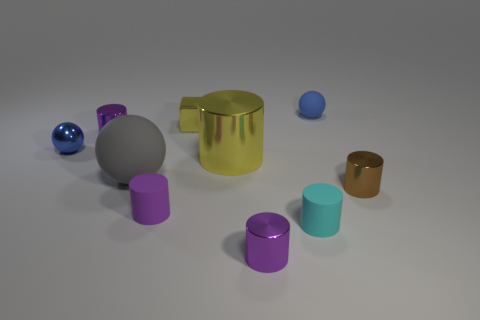What number of objects are small yellow rubber spheres or yellow metallic objects?
Your response must be concise. 2. What is the cylinder that is behind the large gray object and on the right side of the big gray rubber object made of?
Offer a very short reply. Metal. Does the block have the same size as the cyan object?
Give a very brief answer. Yes. There is a yellow metallic object behind the yellow metallic thing in front of the tiny yellow shiny object; how big is it?
Your answer should be very brief. Small. What number of things are both in front of the tiny yellow metal thing and right of the tiny shiny ball?
Ensure brevity in your answer.  7. There is a yellow thing that is on the left side of the large object on the right side of the gray rubber sphere; is there a purple rubber cylinder that is in front of it?
Provide a succinct answer. Yes. There is a blue matte object that is the same size as the cyan cylinder; what shape is it?
Keep it short and to the point. Sphere. Is there a metal thing of the same color as the block?
Provide a succinct answer. Yes. Does the tiny purple rubber object have the same shape as the large metal thing?
Your answer should be compact. Yes. What number of large objects are cyan matte cylinders or purple objects?
Make the answer very short. 0. 